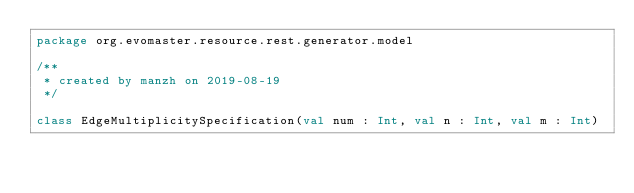Convert code to text. <code><loc_0><loc_0><loc_500><loc_500><_Kotlin_>package org.evomaster.resource.rest.generator.model

/**
 * created by manzh on 2019-08-19
 */

class EdgeMultiplicitySpecification(val num : Int, val n : Int, val m : Int)</code> 